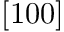<formula> <loc_0><loc_0><loc_500><loc_500>[ 1 0 0 ]</formula> 